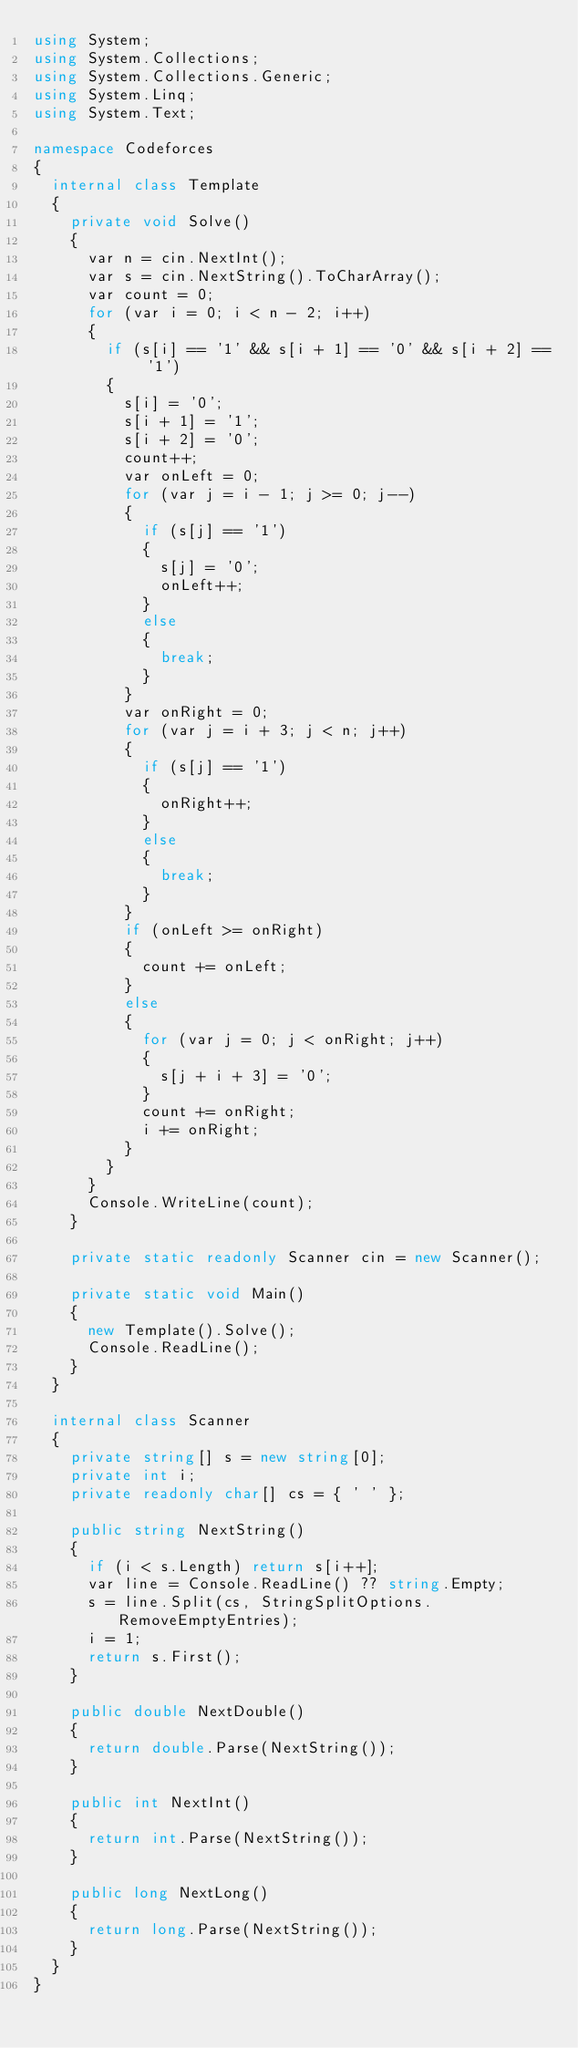<code> <loc_0><loc_0><loc_500><loc_500><_C#_>using System;
using System.Collections;
using System.Collections.Generic;
using System.Linq;
using System.Text;

namespace Codeforces
{
	internal class Template
	{
		private void Solve()
		{
			var n = cin.NextInt();
			var s = cin.NextString().ToCharArray();
			var count = 0;
			for (var i = 0; i < n - 2; i++)
			{
				if (s[i] == '1' && s[i + 1] == '0' && s[i + 2] == '1')
				{
					s[i] = '0';
					s[i + 1] = '1';
					s[i + 2] = '0';
					count++;
					var onLeft = 0;
					for (var j = i - 1; j >= 0; j--)
					{
						if (s[j] == '1')
						{
							s[j] = '0';
							onLeft++;
						}
						else
						{
							break;
						}
					}
					var onRight = 0;
					for (var j = i + 3; j < n; j++)
					{
						if (s[j] == '1')
						{
							onRight++;
						}
						else
						{
							break;
						}
					}
					if (onLeft >= onRight)
					{
						count += onLeft;
					}
					else
					{
						for (var j = 0; j < onRight; j++)
						{
							s[j + i + 3] = '0';
						}
						count += onRight;
						i += onRight;
					}
				}
			}
			Console.WriteLine(count);
		}

		private static readonly Scanner cin = new Scanner();

		private static void Main()
		{
			new Template().Solve();
			Console.ReadLine();
		}
	}

	internal class Scanner
	{
		private string[] s = new string[0];
		private int i;
		private readonly char[] cs = { ' ' };

		public string NextString()
		{
			if (i < s.Length) return s[i++];
			var line = Console.ReadLine() ?? string.Empty;
			s = line.Split(cs, StringSplitOptions.RemoveEmptyEntries);
			i = 1;
			return s.First();
		}

		public double NextDouble()
		{
			return double.Parse(NextString());
		}

		public int NextInt()
		{
			return int.Parse(NextString());
		}

		public long NextLong()
		{
			return long.Parse(NextString());
		}
	}
}</code> 